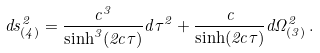Convert formula to latex. <formula><loc_0><loc_0><loc_500><loc_500>d s _ { ( 4 ) } ^ { 2 } = \frac { c ^ { 3 } } { \sinh ^ { 3 } ( 2 c \tau ) } d \tau ^ { 2 } + \frac { c } { \sinh ( 2 c \tau ) } d \Omega ^ { 2 } _ { ( 3 ) } \, .</formula> 